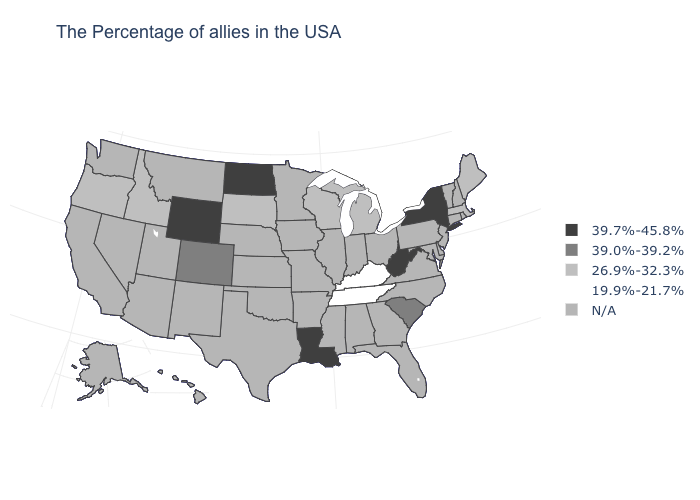Which states have the lowest value in the West?
Quick response, please. Idaho, Oregon. How many symbols are there in the legend?
Short answer required. 5. Name the states that have a value in the range 39.7%-45.8%?
Give a very brief answer. New York, West Virginia, Louisiana, North Dakota, Wyoming. What is the highest value in the West ?
Give a very brief answer. 39.7%-45.8%. What is the value of California?
Concise answer only. N/A. What is the highest value in the USA?
Quick response, please. 39.7%-45.8%. Name the states that have a value in the range 19.9%-21.7%?
Write a very short answer. Kentucky, Tennessee. Which states have the highest value in the USA?
Short answer required. New York, West Virginia, Louisiana, North Dakota, Wyoming. Among the states that border Wyoming , which have the highest value?
Quick response, please. Colorado. Name the states that have a value in the range 26.9%-32.3%?
Write a very short answer. Maine, Massachusetts, Michigan, Wisconsin, South Dakota, Idaho, Oregon. What is the value of Maryland?
Be succinct. N/A. 